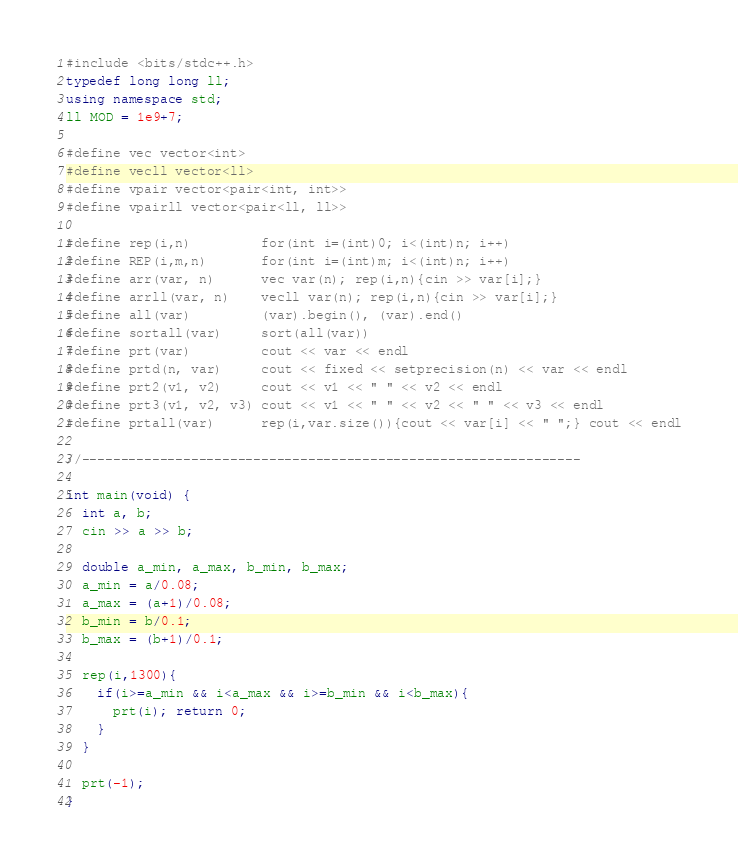Convert code to text. <code><loc_0><loc_0><loc_500><loc_500><_C++_>#include <bits/stdc++.h>
typedef long long ll;
using namespace std;
ll MOD = 1e9+7;

#define vec vector<int>
#define vecll vector<ll>
#define vpair vector<pair<int, int>>
#define vpairll vector<pair<ll, ll>>

#define rep(i,n)         for(int i=(int)0; i<(int)n; i++)
#define REP(i,m,n)       for(int i=(int)m; i<(int)n; i++)
#define arr(var, n)      vec var(n); rep(i,n){cin >> var[i];}
#define arrll(var, n)    vecll var(n); rep(i,n){cin >> var[i];}
#define all(var)         (var).begin(), (var).end()
#define sortall(var)     sort(all(var))
#define prt(var)         cout << var << endl
#define prtd(n, var)     cout << fixed << setprecision(n) << var << endl
#define prt2(v1, v2)     cout << v1 << " " << v2 << endl
#define prt3(v1, v2, v3) cout << v1 << " " << v2 << " " << v3 << endl
#define prtall(var)      rep(i,var.size()){cout << var[i] << " ";} cout << endl

//----------------------------------------------------------------

int main(void) {
  int a, b;
  cin >> a >> b;

  double a_min, a_max, b_min, b_max;
  a_min = a/0.08;
  a_max = (a+1)/0.08;
  b_min = b/0.1;
  b_max = (b+1)/0.1;

  rep(i,1300){
    if(i>=a_min && i<a_max && i>=b_min && i<b_max){
      prt(i); return 0;
    }
  }

  prt(-1);
}
</code> 